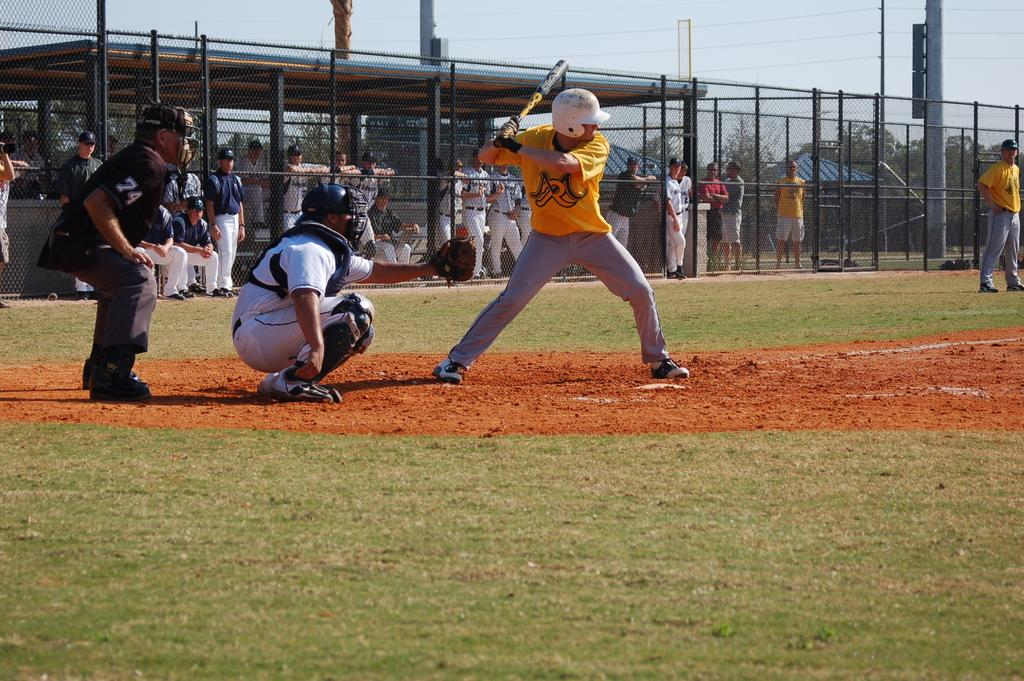<image>
Give a short and clear explanation of the subsequent image. a baseball game with an umpire wearing number 74 on the sleeve 